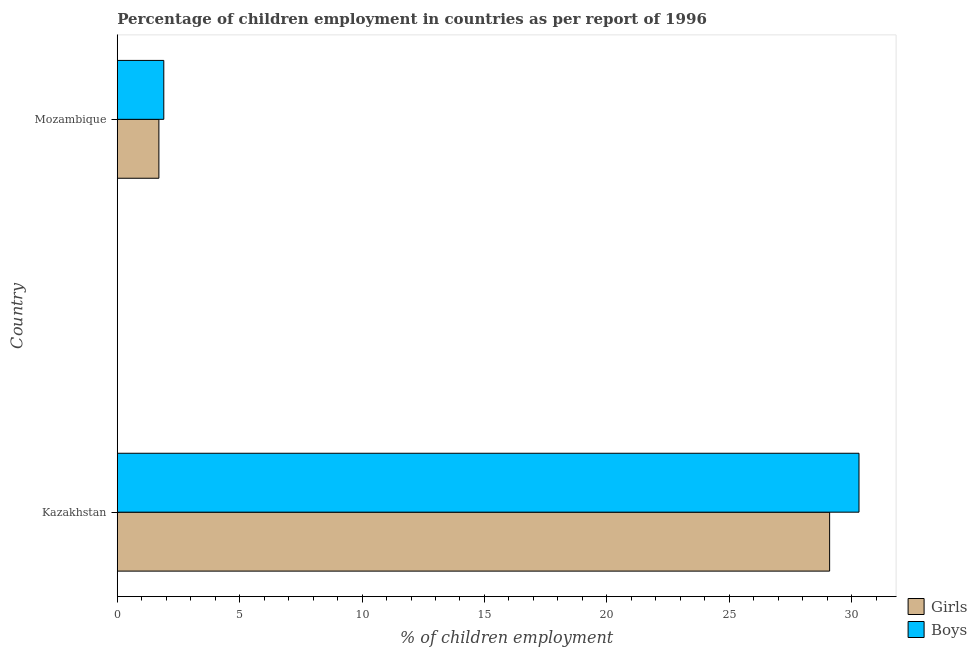What is the label of the 1st group of bars from the top?
Provide a short and direct response. Mozambique. What is the percentage of employed girls in Mozambique?
Your response must be concise. 1.7. Across all countries, what is the maximum percentage of employed boys?
Ensure brevity in your answer.  30.3. Across all countries, what is the minimum percentage of employed girls?
Offer a terse response. 1.7. In which country was the percentage of employed boys maximum?
Ensure brevity in your answer.  Kazakhstan. In which country was the percentage of employed boys minimum?
Ensure brevity in your answer.  Mozambique. What is the total percentage of employed boys in the graph?
Make the answer very short. 32.2. What is the difference between the percentage of employed girls in Kazakhstan and that in Mozambique?
Offer a very short reply. 27.4. What is the difference between the percentage of employed boys in Mozambique and the percentage of employed girls in Kazakhstan?
Your answer should be very brief. -27.2. In how many countries, is the percentage of employed girls greater than 16 %?
Give a very brief answer. 1. What is the ratio of the percentage of employed boys in Kazakhstan to that in Mozambique?
Your answer should be very brief. 15.95. Is the percentage of employed boys in Kazakhstan less than that in Mozambique?
Make the answer very short. No. What does the 1st bar from the top in Mozambique represents?
Your response must be concise. Boys. What does the 1st bar from the bottom in Kazakhstan represents?
Your answer should be compact. Girls. How many bars are there?
Your answer should be very brief. 4. How many countries are there in the graph?
Offer a very short reply. 2. What is the difference between two consecutive major ticks on the X-axis?
Give a very brief answer. 5. Are the values on the major ticks of X-axis written in scientific E-notation?
Give a very brief answer. No. How are the legend labels stacked?
Offer a terse response. Vertical. What is the title of the graph?
Provide a succinct answer. Percentage of children employment in countries as per report of 1996. Does "Number of arrivals" appear as one of the legend labels in the graph?
Provide a succinct answer. No. What is the label or title of the X-axis?
Offer a very short reply. % of children employment. What is the label or title of the Y-axis?
Give a very brief answer. Country. What is the % of children employment in Girls in Kazakhstan?
Offer a terse response. 29.1. What is the % of children employment of Boys in Kazakhstan?
Your answer should be compact. 30.3. Across all countries, what is the maximum % of children employment of Girls?
Make the answer very short. 29.1. Across all countries, what is the maximum % of children employment of Boys?
Ensure brevity in your answer.  30.3. Across all countries, what is the minimum % of children employment of Girls?
Your answer should be compact. 1.7. Across all countries, what is the minimum % of children employment in Boys?
Offer a terse response. 1.9. What is the total % of children employment of Girls in the graph?
Give a very brief answer. 30.8. What is the total % of children employment in Boys in the graph?
Make the answer very short. 32.2. What is the difference between the % of children employment in Girls in Kazakhstan and that in Mozambique?
Your answer should be compact. 27.4. What is the difference between the % of children employment in Boys in Kazakhstan and that in Mozambique?
Make the answer very short. 28.4. What is the difference between the % of children employment of Girls in Kazakhstan and the % of children employment of Boys in Mozambique?
Provide a succinct answer. 27.2. What is the ratio of the % of children employment of Girls in Kazakhstan to that in Mozambique?
Make the answer very short. 17.12. What is the ratio of the % of children employment of Boys in Kazakhstan to that in Mozambique?
Offer a terse response. 15.95. What is the difference between the highest and the second highest % of children employment in Girls?
Give a very brief answer. 27.4. What is the difference between the highest and the second highest % of children employment in Boys?
Offer a terse response. 28.4. What is the difference between the highest and the lowest % of children employment of Girls?
Provide a succinct answer. 27.4. What is the difference between the highest and the lowest % of children employment in Boys?
Give a very brief answer. 28.4. 